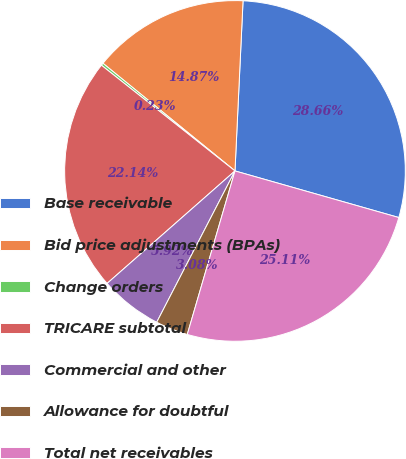Convert chart. <chart><loc_0><loc_0><loc_500><loc_500><pie_chart><fcel>Base receivable<fcel>Bid price adjustments (BPAs)<fcel>Change orders<fcel>TRICARE subtotal<fcel>Commercial and other<fcel>Allowance for doubtful<fcel>Total net receivables<nl><fcel>28.66%<fcel>14.87%<fcel>0.23%<fcel>22.14%<fcel>5.92%<fcel>3.08%<fcel>25.11%<nl></chart> 